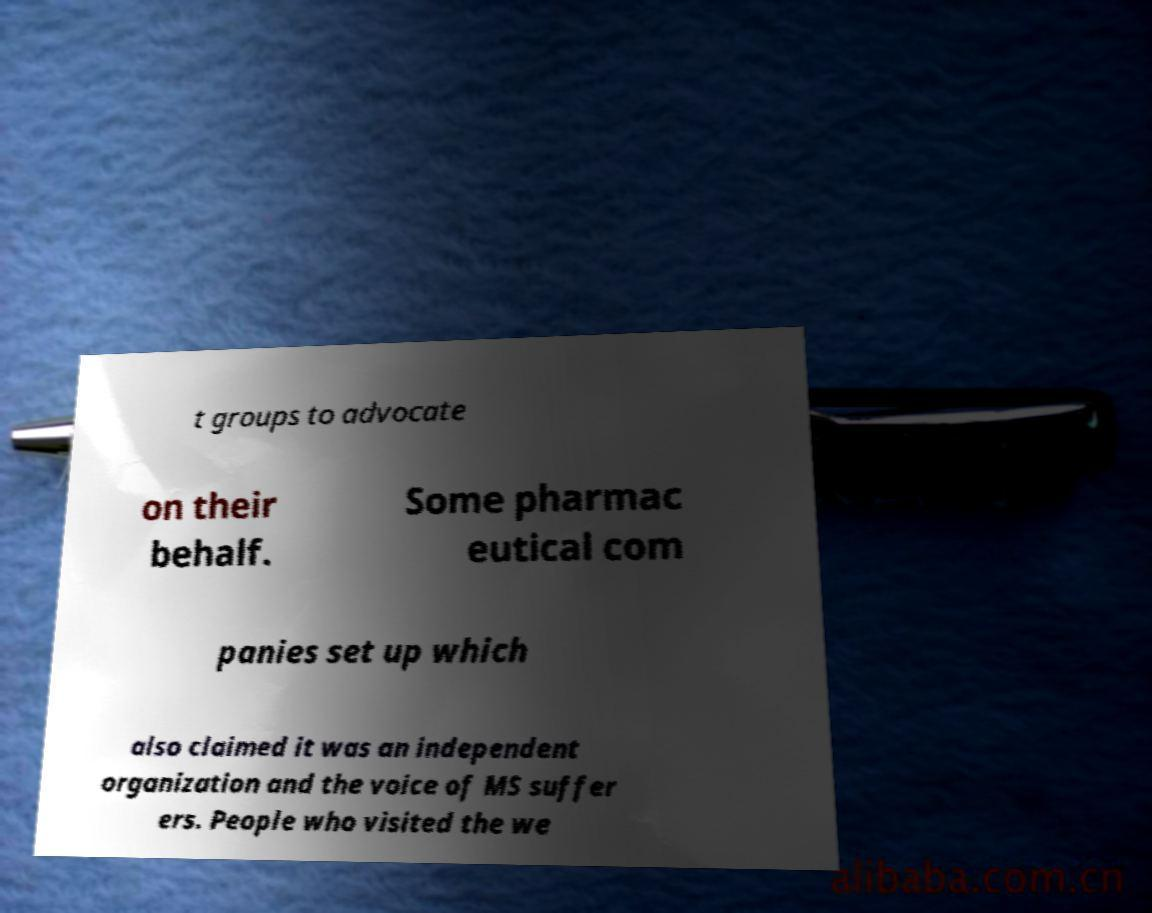I need the written content from this picture converted into text. Can you do that? t groups to advocate on their behalf. Some pharmac eutical com panies set up which also claimed it was an independent organization and the voice of MS suffer ers. People who visited the we 